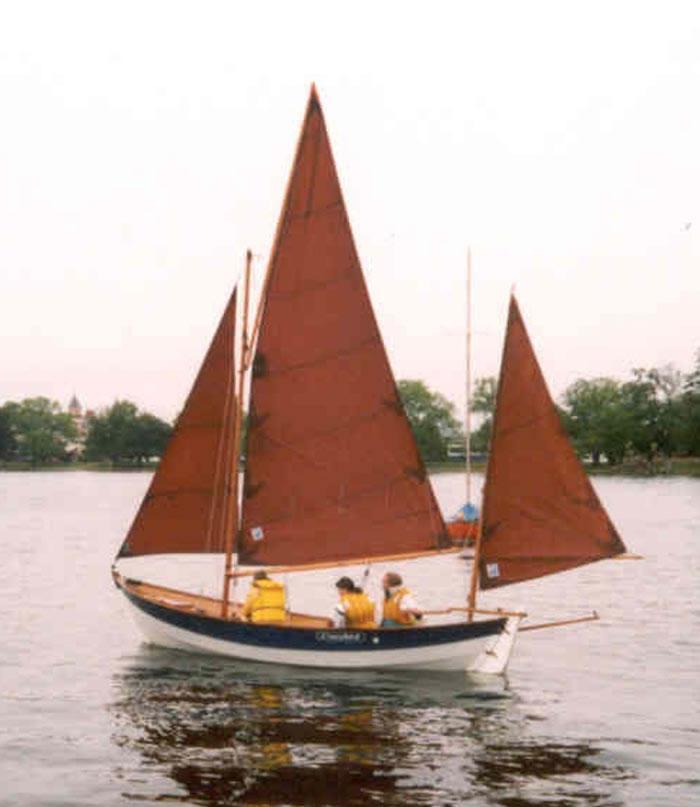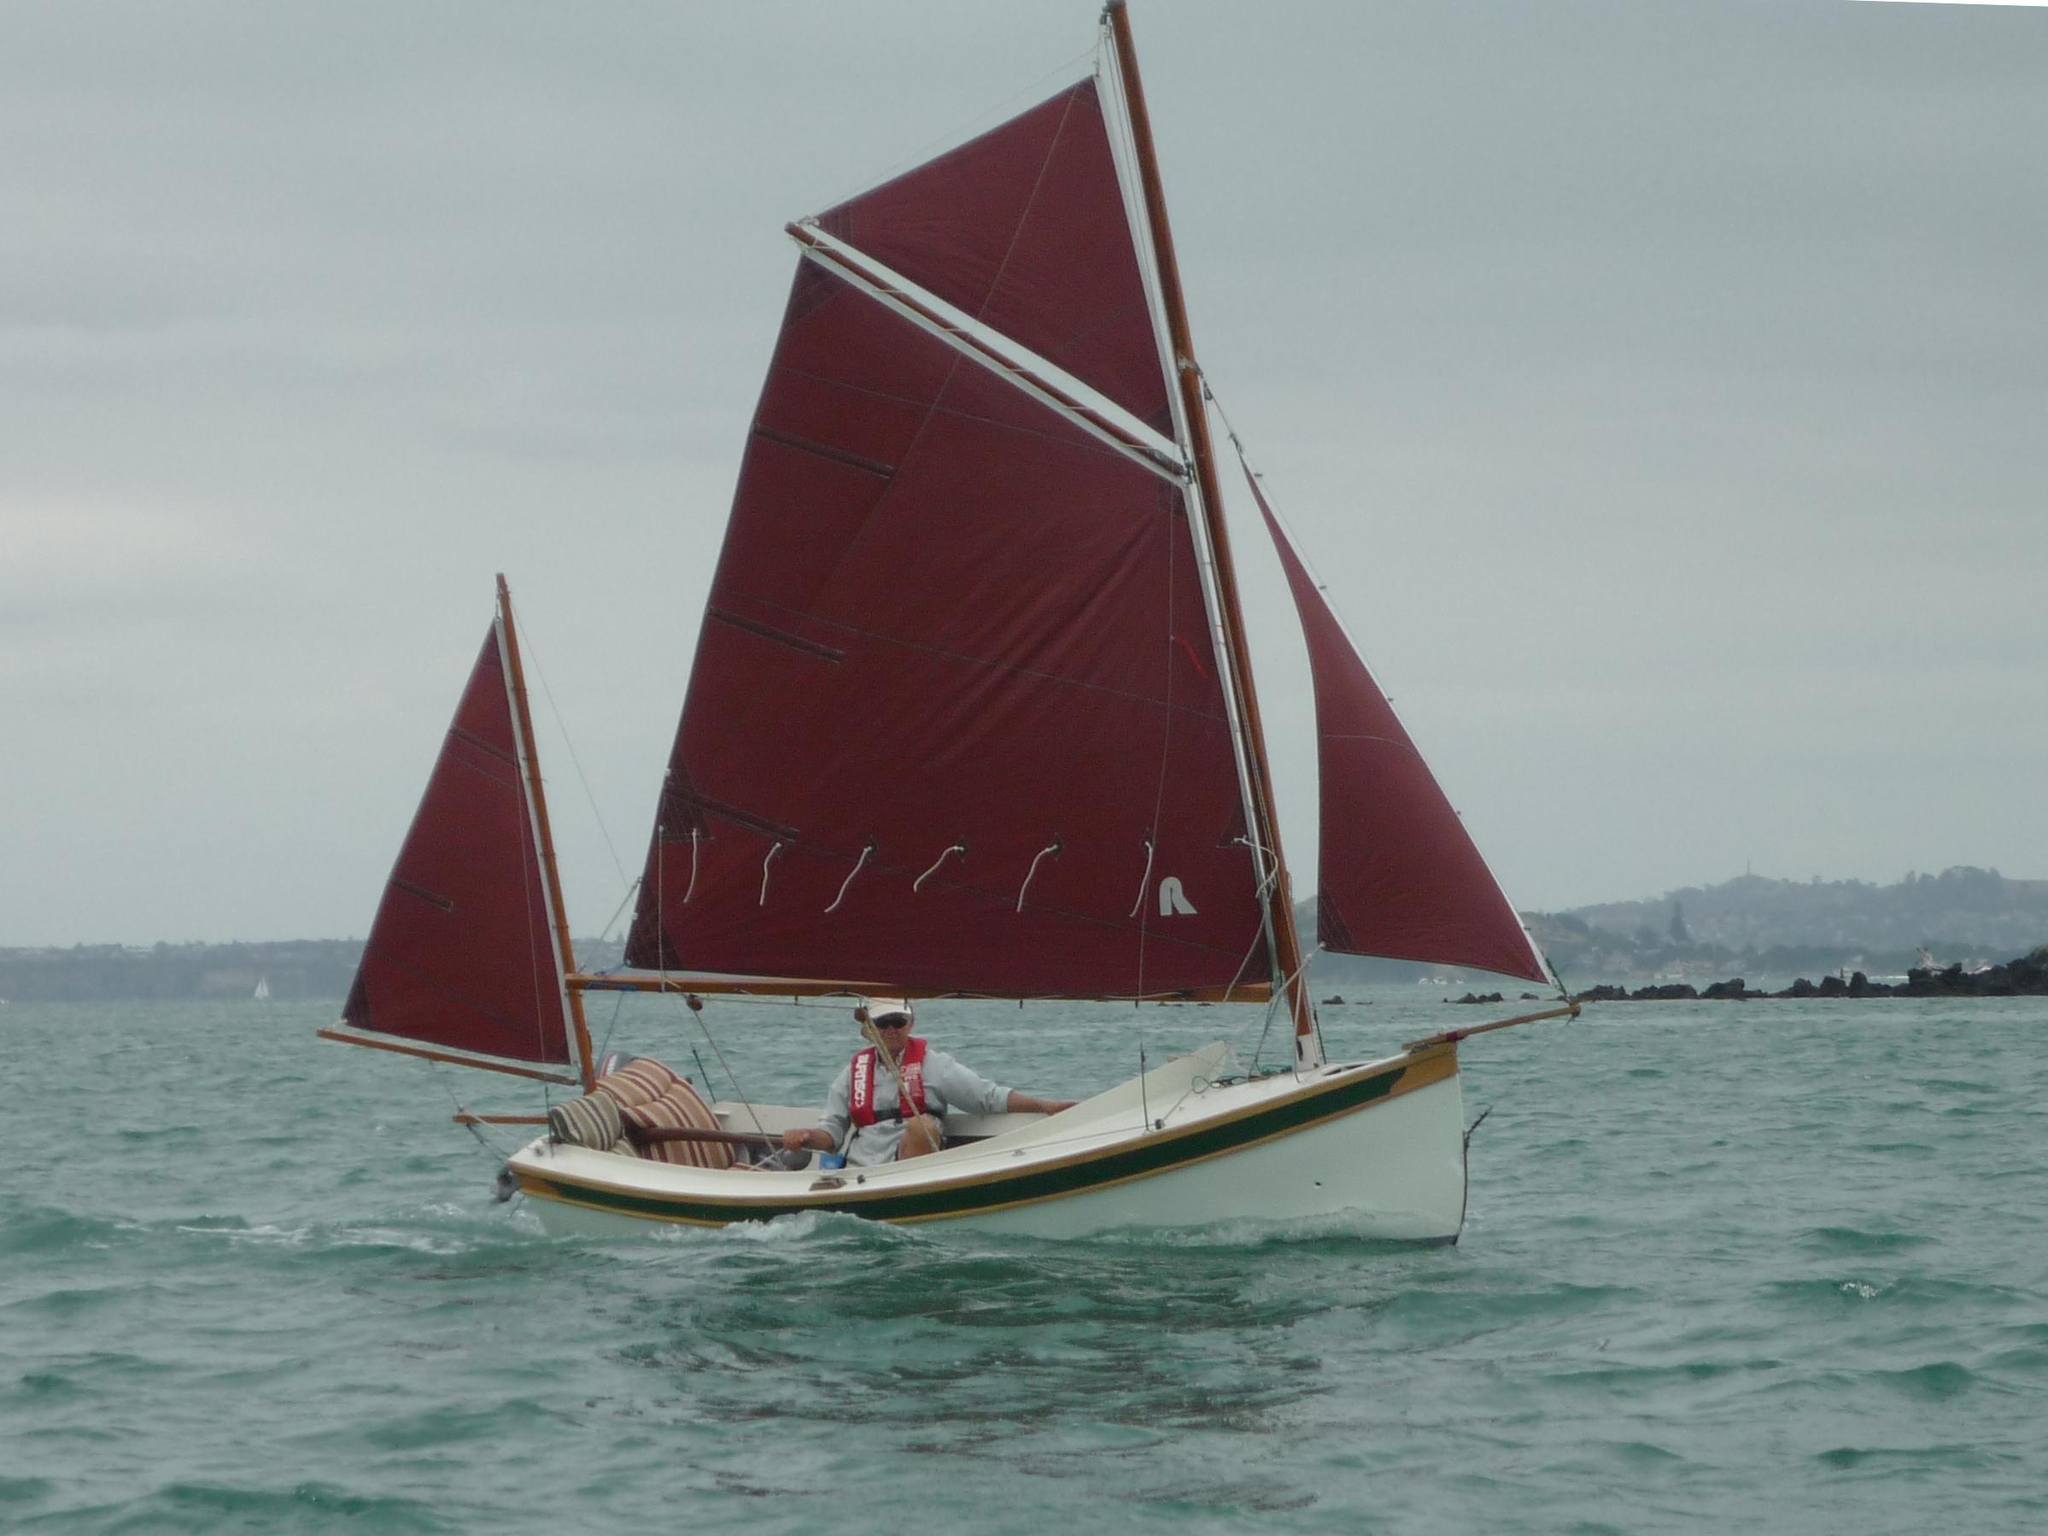The first image is the image on the left, the second image is the image on the right. Evaluate the accuracy of this statement regarding the images: "A sailboat with red sails is in the water.". Is it true? Answer yes or no. Yes. 